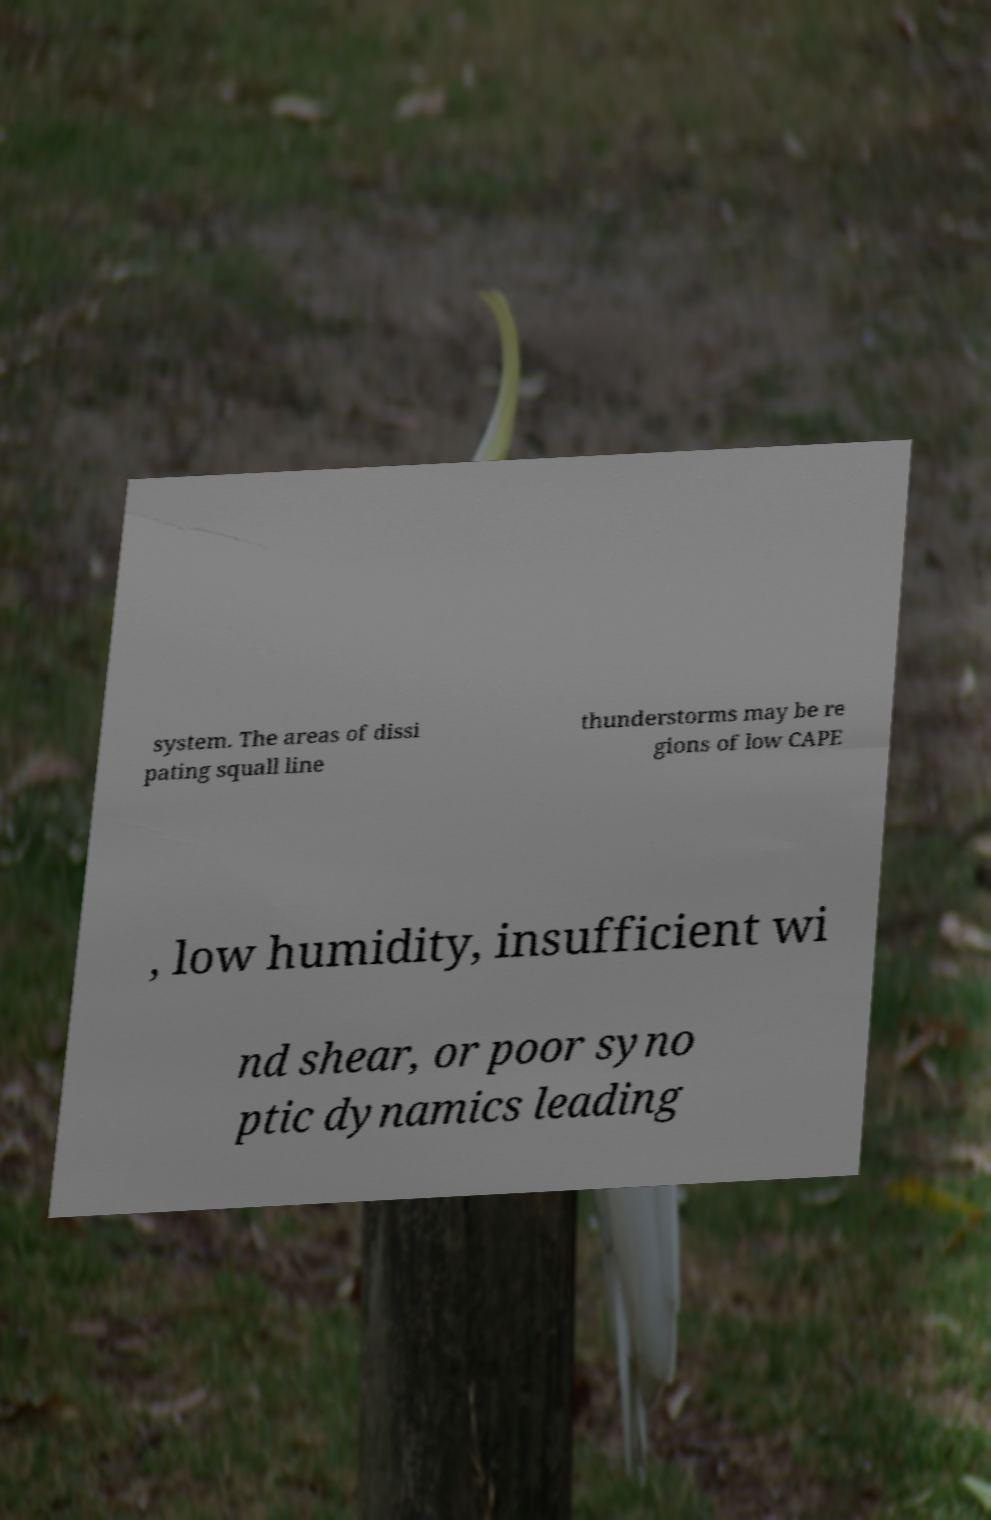For documentation purposes, I need the text within this image transcribed. Could you provide that? system. The areas of dissi pating squall line thunderstorms may be re gions of low CAPE , low humidity, insufficient wi nd shear, or poor syno ptic dynamics leading 